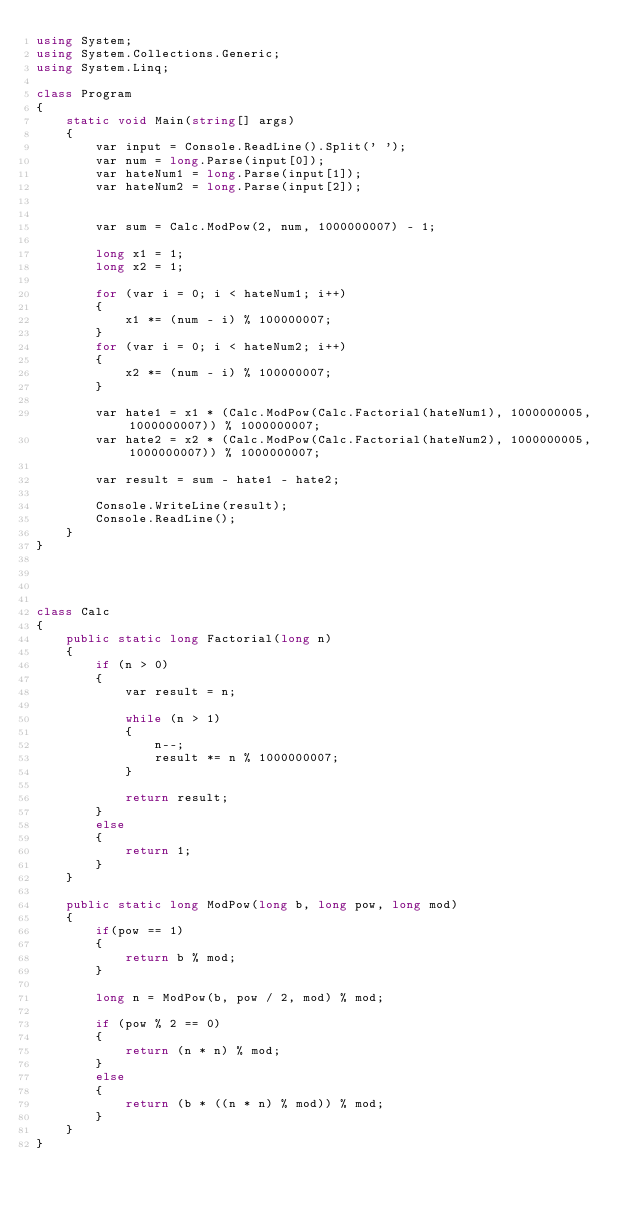Convert code to text. <code><loc_0><loc_0><loc_500><loc_500><_C#_>using System;
using System.Collections.Generic;
using System.Linq;

class Program
{
    static void Main(string[] args)
    {
        var input = Console.ReadLine().Split(' ');
        var num = long.Parse(input[0]);
        var hateNum1 = long.Parse(input[1]);
        var hateNum2 = long.Parse(input[2]);


        var sum = Calc.ModPow(2, num, 1000000007) - 1;

        long x1 = 1;
        long x2 = 1;

        for (var i = 0; i < hateNum1; i++)
        {
            x1 *= (num - i) % 100000007;
        }
        for (var i = 0; i < hateNum2; i++)
        {
            x2 *= (num - i) % 100000007;
        }

        var hate1 = x1 * (Calc.ModPow(Calc.Factorial(hateNum1), 1000000005, 1000000007)) % 1000000007;
        var hate2 = x2 * (Calc.ModPow(Calc.Factorial(hateNum2), 1000000005, 1000000007)) % 1000000007;

        var result = sum - hate1 - hate2;

        Console.WriteLine(result);
        Console.ReadLine();
    }
}




class Calc
{
    public static long Factorial(long n)
    {
        if (n > 0)
        {
            var result = n;

            while (n > 1)
            {
                n--;
                result *= n % 1000000007;
            }

            return result;
        }
        else
        {
            return 1;
        }
    }

    public static long ModPow(long b, long pow, long mod)
    {
        if(pow == 1)
        {
            return b % mod;
        }

        long n = ModPow(b, pow / 2, mod) % mod;

        if (pow % 2 == 0)
        {
            return (n * n) % mod;
        }
        else
        {
            return (b * ((n * n) % mod)) % mod;
        }
    }
}</code> 